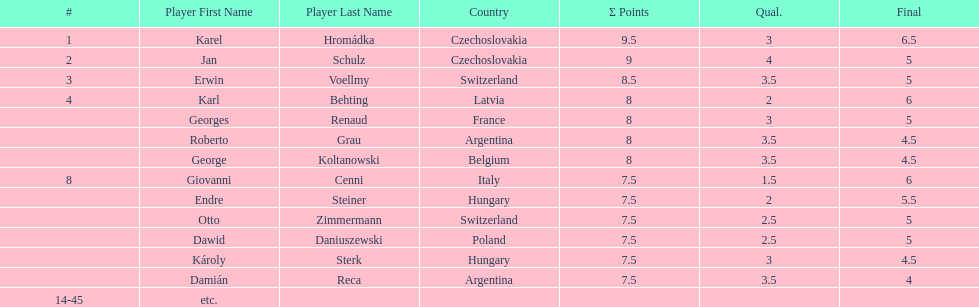Parse the full table. {'header': ['#', 'Player First Name', 'Player Last Name', 'Country', 'Σ Points', 'Qual.', 'Final'], 'rows': [['1', 'Karel', 'Hromádka', 'Czechoslovakia', '9.5', '3', '6.5'], ['2', 'Jan', 'Schulz', 'Czechoslovakia', '9', '4', '5'], ['3', 'Erwin', 'Voellmy', 'Switzerland', '8.5', '3.5', '5'], ['4', 'Karl', 'Behting', 'Latvia', '8', '2', '6'], ['', 'Georges', 'Renaud', 'France', '8', '3', '5'], ['', 'Roberto', 'Grau', 'Argentina', '8', '3.5', '4.5'], ['', 'George', 'Koltanowski', 'Belgium', '8', '3.5', '4.5'], ['8', 'Giovanni', 'Cenni', 'Italy', '7.5', '1.5', '6'], ['', 'Endre', 'Steiner', 'Hungary', '7.5', '2', '5.5'], ['', 'Otto', 'Zimmermann', 'Switzerland', '7.5', '2.5', '5'], ['', 'Dawid', 'Daniuszewski', 'Poland', '7.5', '2.5', '5'], ['', 'Károly', 'Sterk', 'Hungary', '7.5', '3', '4.5'], ['', 'Damián', 'Reca', 'Argentina', '7.5', '3.5', '4'], ['14-45', 'etc.', '', '', '', '', '']]} The most points were scored by which player? Karel Hromádka. 